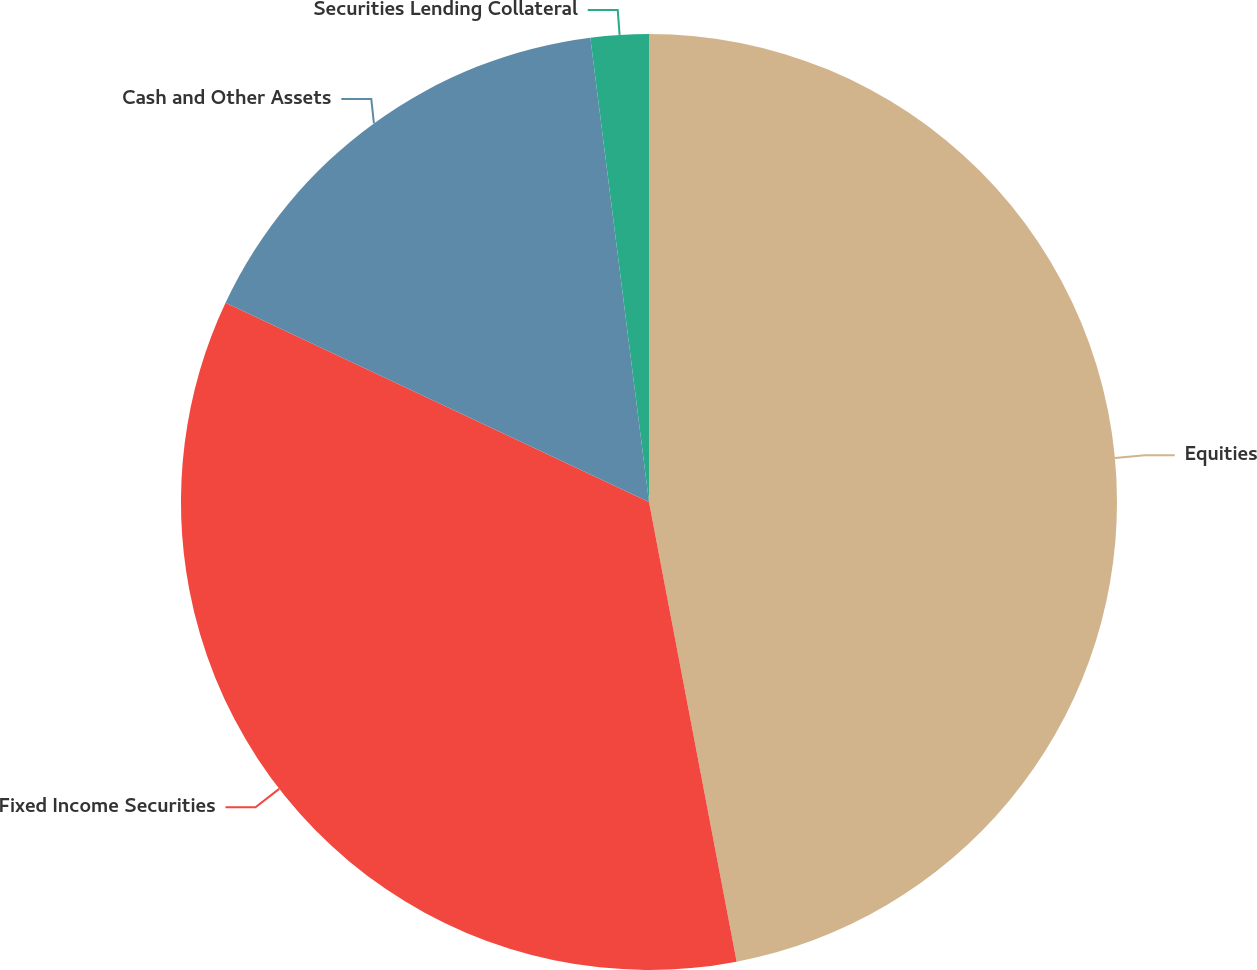<chart> <loc_0><loc_0><loc_500><loc_500><pie_chart><fcel>Equities<fcel>Fixed Income Securities<fcel>Cash and Other Assets<fcel>Securities Lending Collateral<nl><fcel>47.0%<fcel>35.0%<fcel>16.0%<fcel>2.0%<nl></chart> 